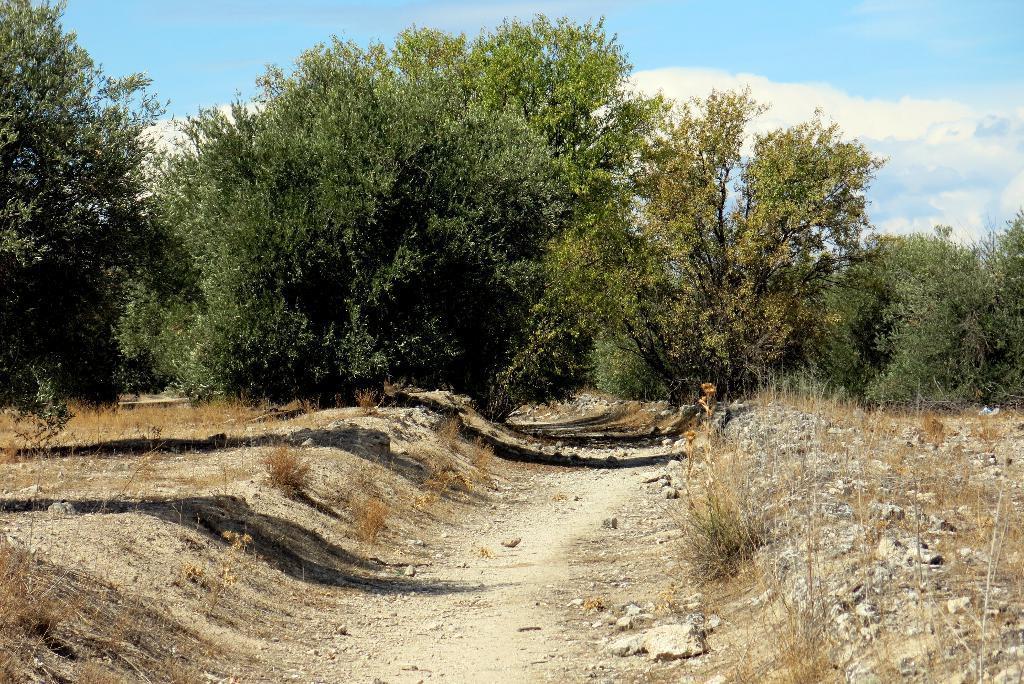Describe this image in one or two sentences. This image consists of a path. On the left and right, we can see dry grass on the ground. In the background, there are trees. At the top, there are clouds in the sky. 